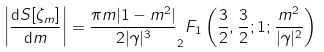Convert formula to latex. <formula><loc_0><loc_0><loc_500><loc_500>\left | \frac { \mathrm d S [ \zeta _ { m } ] } { \mathrm d m } \right | = \frac { \pi m | 1 - m ^ { 2 } | } { 2 | \gamma | ^ { 3 } } _ { 2 } F _ { 1 } \left ( \frac { 3 } { 2 } , \frac { 3 } { 2 } ; 1 ; \frac { m ^ { 2 } } { | \gamma | ^ { 2 } } \right )</formula> 